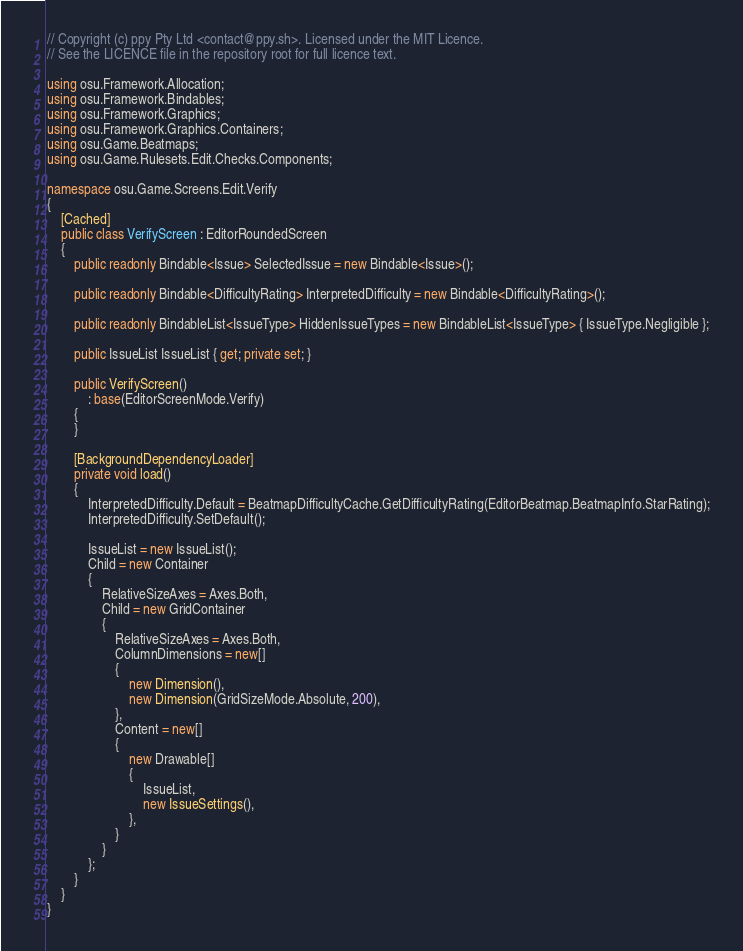Convert code to text. <code><loc_0><loc_0><loc_500><loc_500><_C#_>// Copyright (c) ppy Pty Ltd <contact@ppy.sh>. Licensed under the MIT Licence.
// See the LICENCE file in the repository root for full licence text.

using osu.Framework.Allocation;
using osu.Framework.Bindables;
using osu.Framework.Graphics;
using osu.Framework.Graphics.Containers;
using osu.Game.Beatmaps;
using osu.Game.Rulesets.Edit.Checks.Components;

namespace osu.Game.Screens.Edit.Verify
{
    [Cached]
    public class VerifyScreen : EditorRoundedScreen
    {
        public readonly Bindable<Issue> SelectedIssue = new Bindable<Issue>();

        public readonly Bindable<DifficultyRating> InterpretedDifficulty = new Bindable<DifficultyRating>();

        public readonly BindableList<IssueType> HiddenIssueTypes = new BindableList<IssueType> { IssueType.Negligible };

        public IssueList IssueList { get; private set; }

        public VerifyScreen()
            : base(EditorScreenMode.Verify)
        {
        }

        [BackgroundDependencyLoader]
        private void load()
        {
            InterpretedDifficulty.Default = BeatmapDifficultyCache.GetDifficultyRating(EditorBeatmap.BeatmapInfo.StarRating);
            InterpretedDifficulty.SetDefault();

            IssueList = new IssueList();
            Child = new Container
            {
                RelativeSizeAxes = Axes.Both,
                Child = new GridContainer
                {
                    RelativeSizeAxes = Axes.Both,
                    ColumnDimensions = new[]
                    {
                        new Dimension(),
                        new Dimension(GridSizeMode.Absolute, 200),
                    },
                    Content = new[]
                    {
                        new Drawable[]
                        {
                            IssueList,
                            new IssueSettings(),
                        },
                    }
                }
            };
        }
    }
}
</code> 